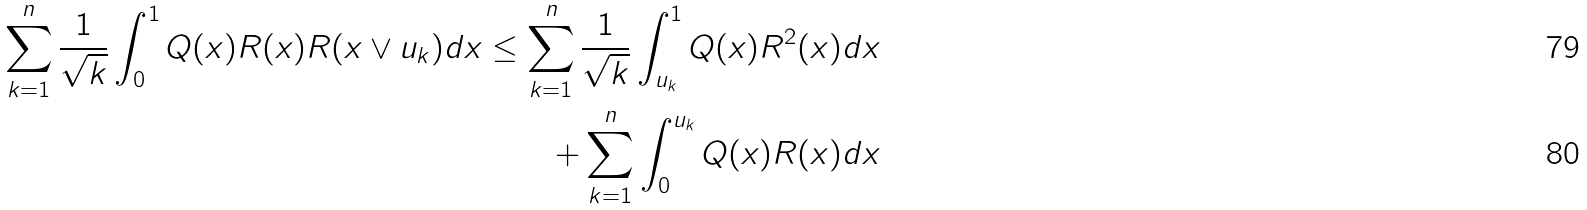Convert formula to latex. <formula><loc_0><loc_0><loc_500><loc_500>\sum _ { k = 1 } ^ { n } \frac { 1 } { \sqrt { k } } \int _ { 0 } ^ { 1 } Q ( x ) R ( x ) R ( x \vee u _ { k } ) d x \leq \sum _ { k = 1 } ^ { n } \frac { 1 } { \sqrt { k } } \int _ { u _ { k } } ^ { 1 } Q ( x ) R ^ { 2 } ( x ) d x \\ + \sum _ { k = 1 } ^ { n } \int _ { 0 } ^ { u _ { k } } Q ( x ) R ( x ) d x</formula> 